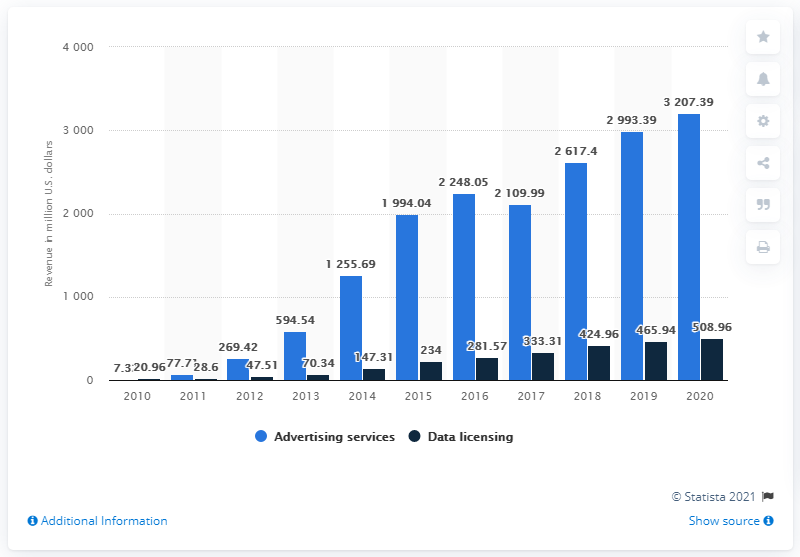How much advertising revenue did Twitter generate in the most recent fiscal period? In the most recent fiscal period, which is 2020 as depicted in the provided chart, Twitter generated $3.207.39 million in advertising revenue. 